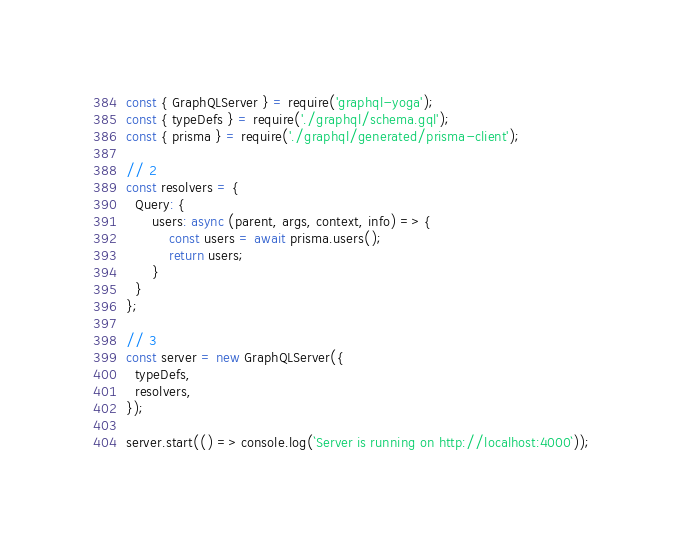Convert code to text. <code><loc_0><loc_0><loc_500><loc_500><_JavaScript_>const { GraphQLServer } = require('graphql-yoga');
const { typeDefs } = require('./graphql/schema.gql');
const { prisma } = require('./graphql/generated/prisma-client');

// 2
const resolvers = {
  Query: {
      users: async (parent, args, context, info) => {
          const users = await prisma.users();
          return users;
      }
  }
};

// 3
const server = new GraphQLServer({
  typeDefs,
  resolvers,
});

server.start(() => console.log(`Server is running on http://localhost:4000`));</code> 